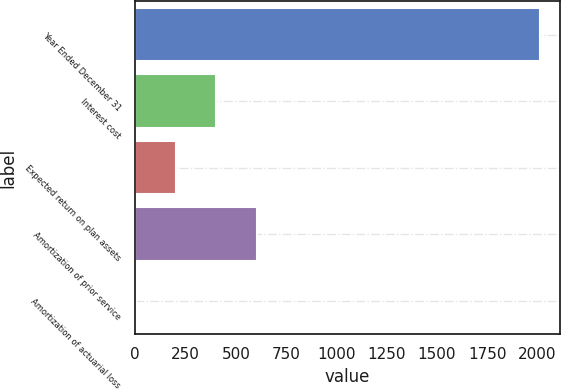Convert chart to OTSL. <chart><loc_0><loc_0><loc_500><loc_500><bar_chart><fcel>Year Ended December 31<fcel>Interest cost<fcel>Expected return on plan assets<fcel>Amortization of prior service<fcel>Amortization of actuarial loss<nl><fcel>2011<fcel>403.8<fcel>202.9<fcel>604.7<fcel>2<nl></chart> 